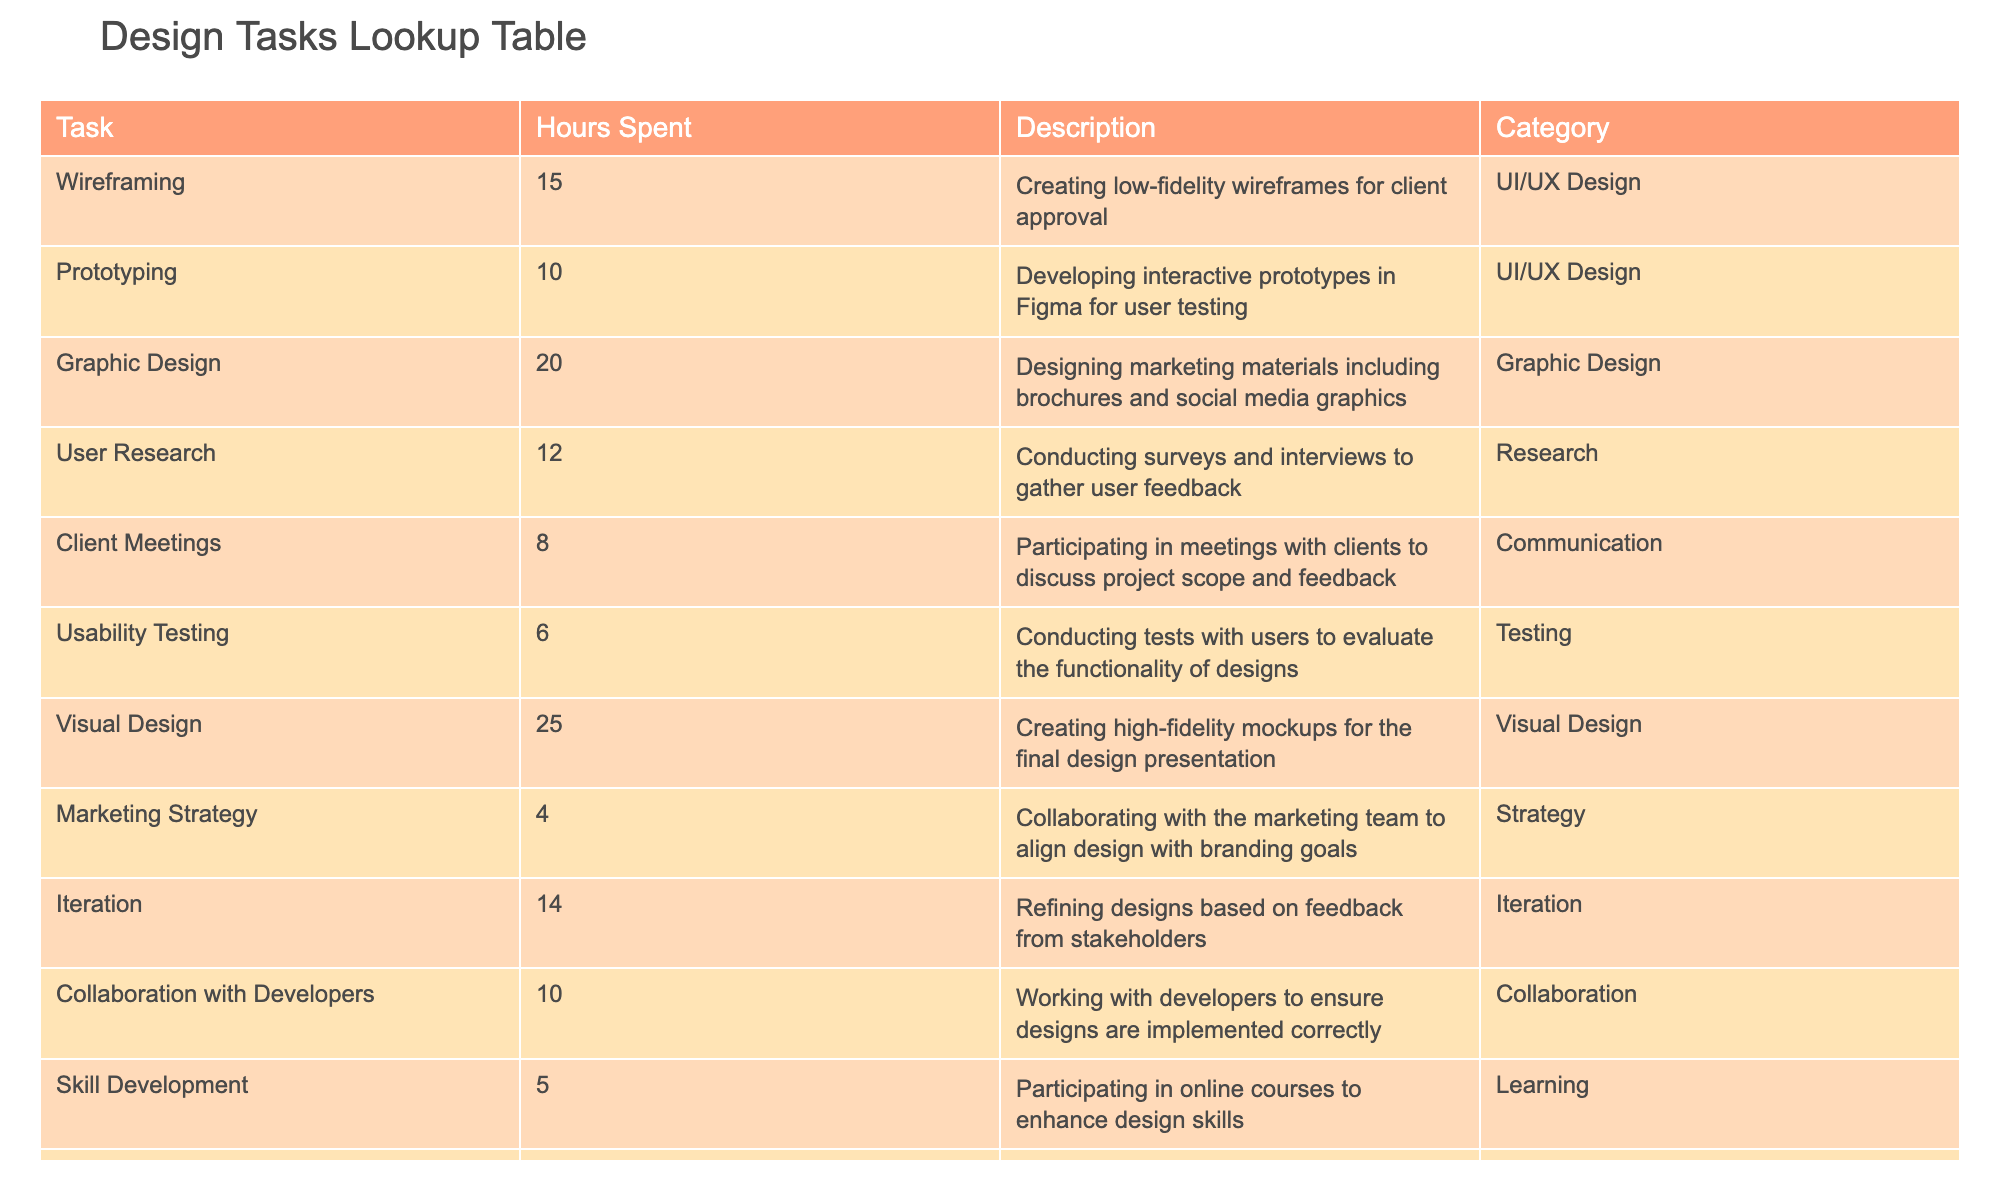What is the total time spent on UI/UX Design tasks? To find the total time spent on UI/UX Design tasks, we look at the relevant tasks in the table: Wireframing (15 hours) and Prototyping (10 hours). Adding these gives 15 + 10 = 25 hours.
Answer: 25 hours What task required the most time? By examining the "Hours Spent" column, we find that Visual Design has the highest value at 25 hours, making it the task that required the most time.
Answer: Visual Design Is more time spent on graphic design or user research? Graphic Design took 20 hours, while User Research took 12 hours. Since 20 is greater than 12, more time was spent on Graphic Design.
Answer: More time was spent on Graphic Design What is the average time spent on all tasks? First, sum the hours spent on all tasks: 15 + 10 + 20 + 12 + 8 + 6 + 25 + 4 + 14 + 10 + 5 + 7 + 3 =  14.8. There are 13 tasks in total. Therefore, the average time spent is 186/13 ≈ 14.3 hours.
Answer: About 14.3 hours Did more hours get spent on Iteration than Client Meetings? Iteration took 14 hours while Client Meetings took 8 hours. Since 14 is greater than 8, the answer is yes.
Answer: Yes What is the combined time spent on Learning and Documentation tasks? The time spent on Skill Development (Learning) is 5 hours and on Documentation is 3 hours. Adding these together gives 5 + 3 = 8 hours.
Answer: 8 hours How many tasks took less than 10 hours? The tasks with less than 10 hours are: Usability Testing (6 hours), Marketing Strategy (4 hours), Skill Development (5 hours), and Documentation (3 hours), totaling 4 tasks.
Answer: 4 tasks What is the time difference between the task with the highest and the lowest hours spent? The highest is Visual Design with 25 hours and the lowest is Documentation with 3 hours. The difference is 25 - 3 = 22 hours.
Answer: 22 hours Which category had the least amount of time spent? Looking at the categories, Marketing Strategy stands out with only 4 hours, which is the least compared to others.
Answer: Marketing Strategy 